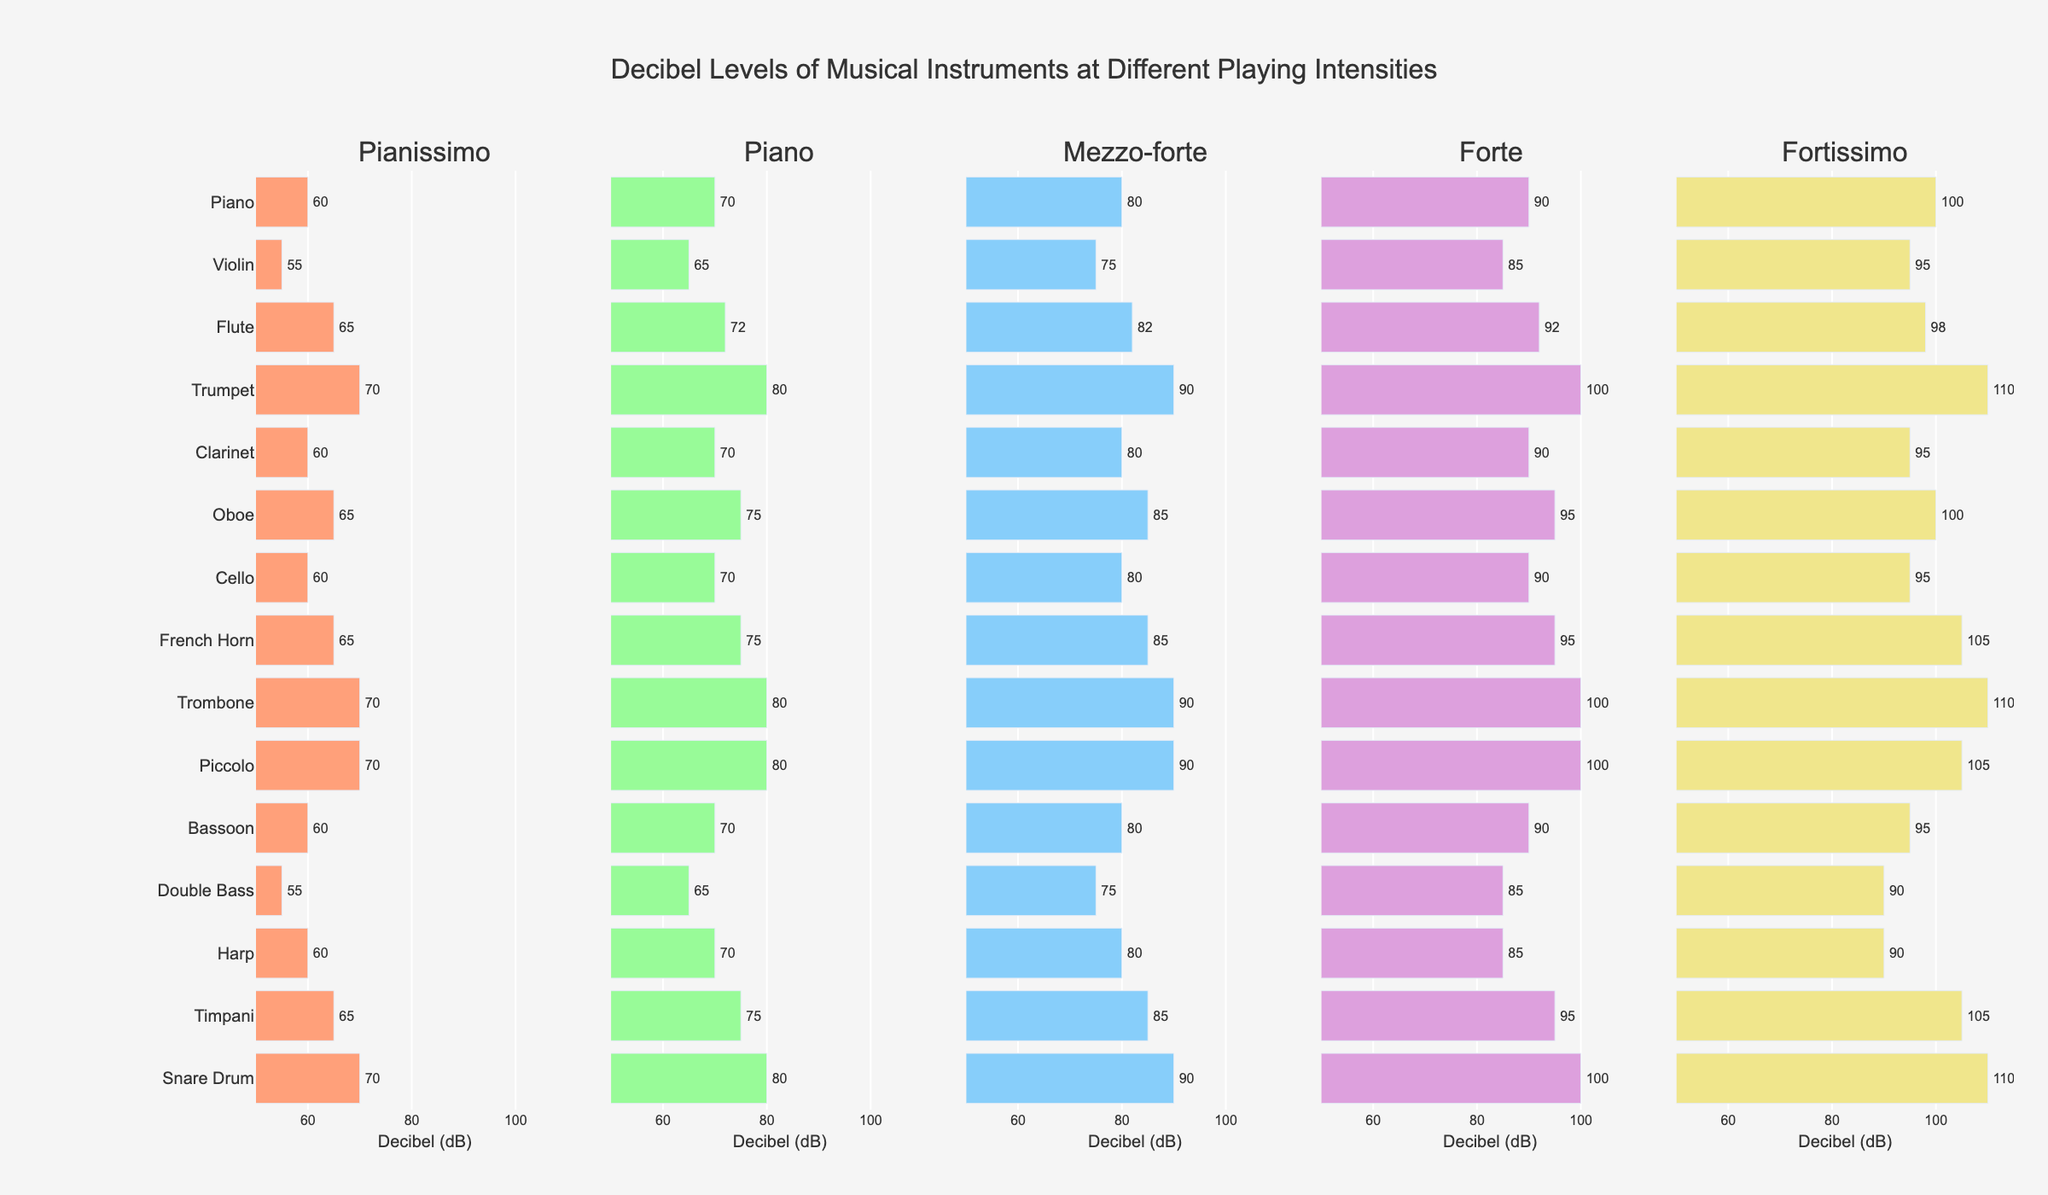What instrument produces the highest decibel level at Fortissimo? Look at the Fortissimo (dB) column and identify the instrument with the highest bar. The Trumpet, Trombone, and Snare Drum all have bars reaching 110 dB.
Answer: Trumpet, Trombone, Snare Drum Which instrument has the lowest decibel level at Pianissimo? Look at the Pianissimo (dB) column and find the shortest bar. The Double Bass has the shortest bar at 55 dB.
Answer: Double Bass What's the average decibel level of the Oboe across all playing intensities? Sum the decibel values for the Oboe across all intensities and divide by the number of intensities: \( (65 + 75 + 85 + 95 + 100) / 5 = 420 / 5 \)
Answer: 84 Is the decibel level for the Flute at Forte higher or lower than the decibel level for the Piano at Mezzo-forte? Compare the height of the bar for Flute at Forte (92 dB) with the height of the bar for Piano at Mezzo-forte (80 dB). Since 92 > 80, the Flute at Forte is higher.
Answer: Higher How much does the decibel level of the Timpani increase from Pianissimo to Fortissimo? Subtract the decibel value at Pianissimo from the value at Fortissimo for the Timpani: \( 105 - 65 = 40 \)
Answer: 40 Which instruments have the same decibel level at Piano? Identify the instruments with bars at 70 dB in the Piano (dB) column. The Piano, Clarinet, Cello, Bassoon, and Harp all have bars at 70 dB.
Answer: Piano, Clarinet, Cello, Bassoon, Harp What is the total decibel level of the French Horn and Snare Drum at Mezzo-forte? Add the decibel values for the French Horn and Snare Drum at Mezzo-forte: \( 85 + 90 = 175 \)
Answer: 175 How much higher in decibels is the Forte level of the Trombone compared to the Piano at the same intensity? Subtract the decibel level of the Piano from the Trombone at Forte: \( 100 - 90 = 10 \)
Answer: 10 Which instrument has the greatest increase in decibels from Piano to Fortissimo? Calculate the increase for each instrument by subtracting the Piano level from the Fortissimo level, and find the greatest increase. For Trumpet and Trombone, the increase is \( 110 - 80 = 30 \), which is the highest.
Answer: Trumpet, Trombone 